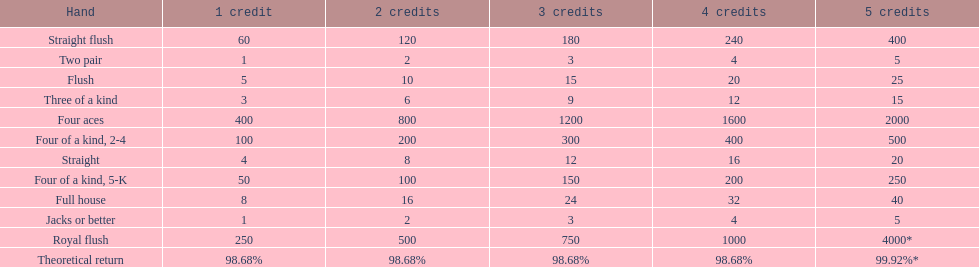How many credits do you have to spend to get at least 2000 in payout if you had four aces? 5 credits. 